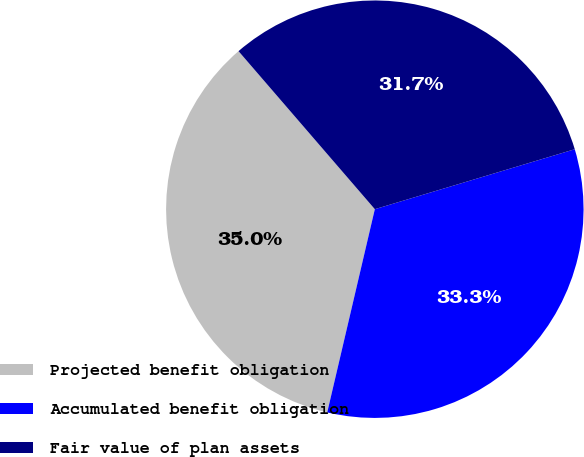Convert chart. <chart><loc_0><loc_0><loc_500><loc_500><pie_chart><fcel>Projected benefit obligation<fcel>Accumulated benefit obligation<fcel>Fair value of plan assets<nl><fcel>35.01%<fcel>33.3%<fcel>31.69%<nl></chart> 